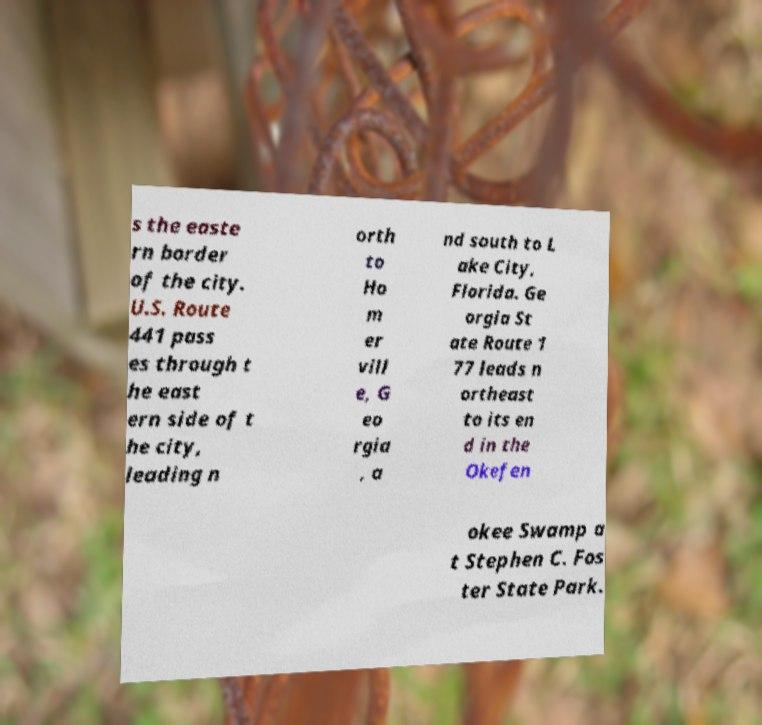Could you extract and type out the text from this image? s the easte rn border of the city. U.S. Route 441 pass es through t he east ern side of t he city, leading n orth to Ho m er vill e, G eo rgia , a nd south to L ake City, Florida. Ge orgia St ate Route 1 77 leads n ortheast to its en d in the Okefen okee Swamp a t Stephen C. Fos ter State Park. 